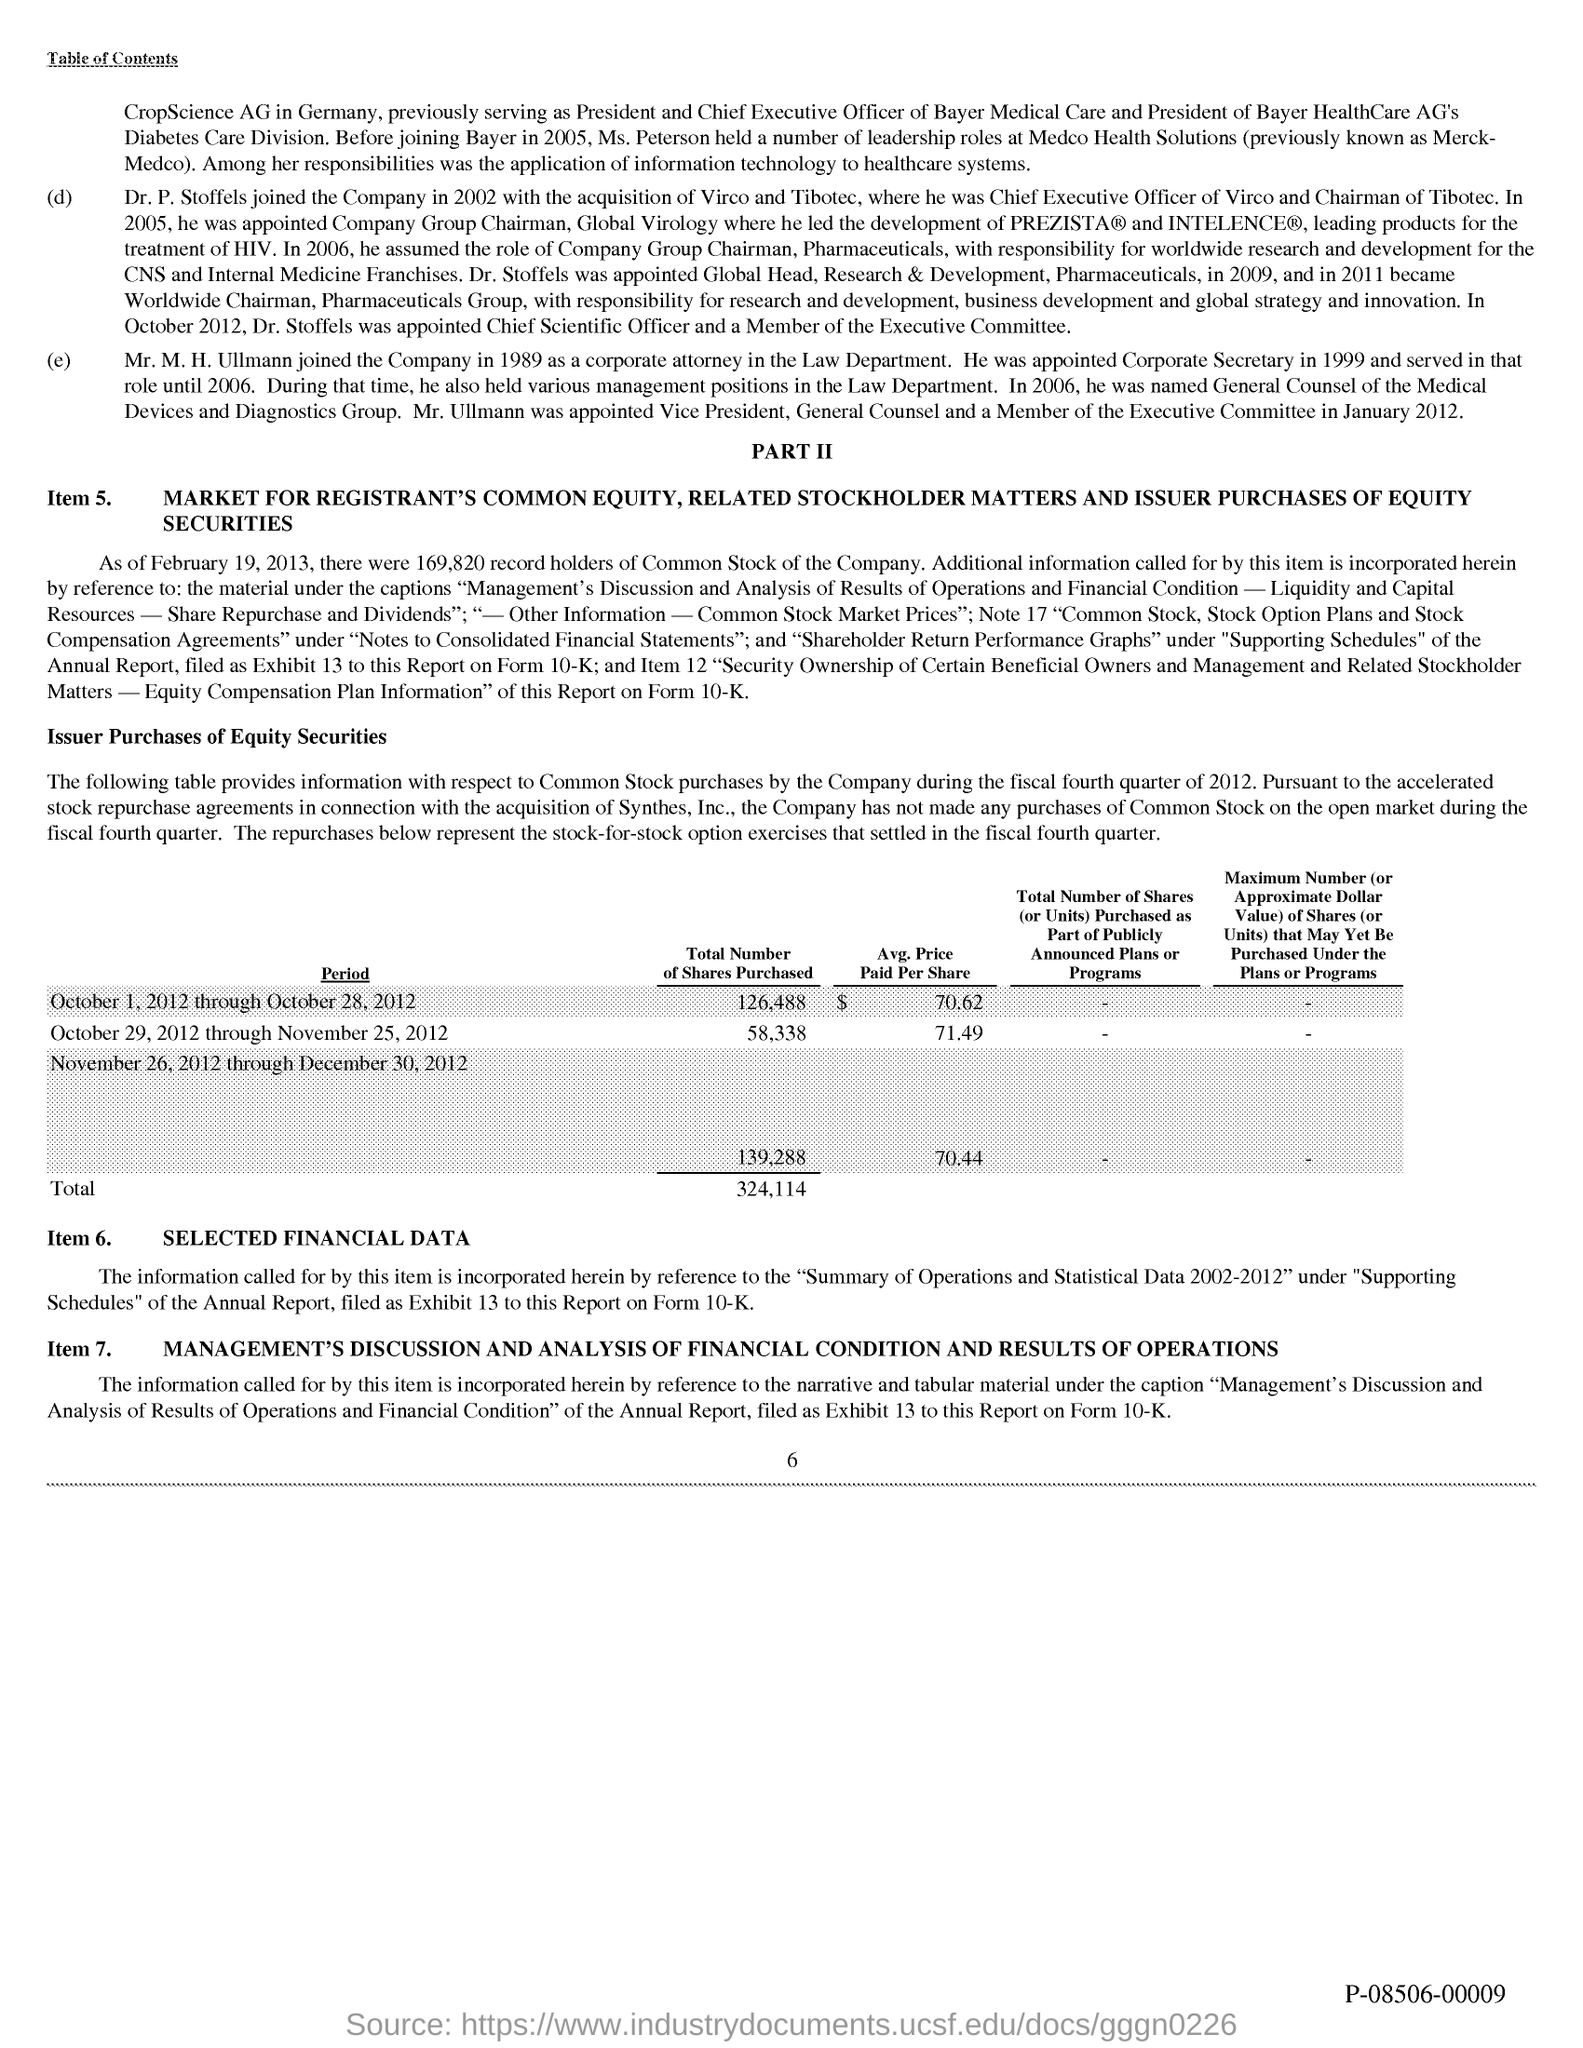What is the Page Number?
Your response must be concise. 6. 